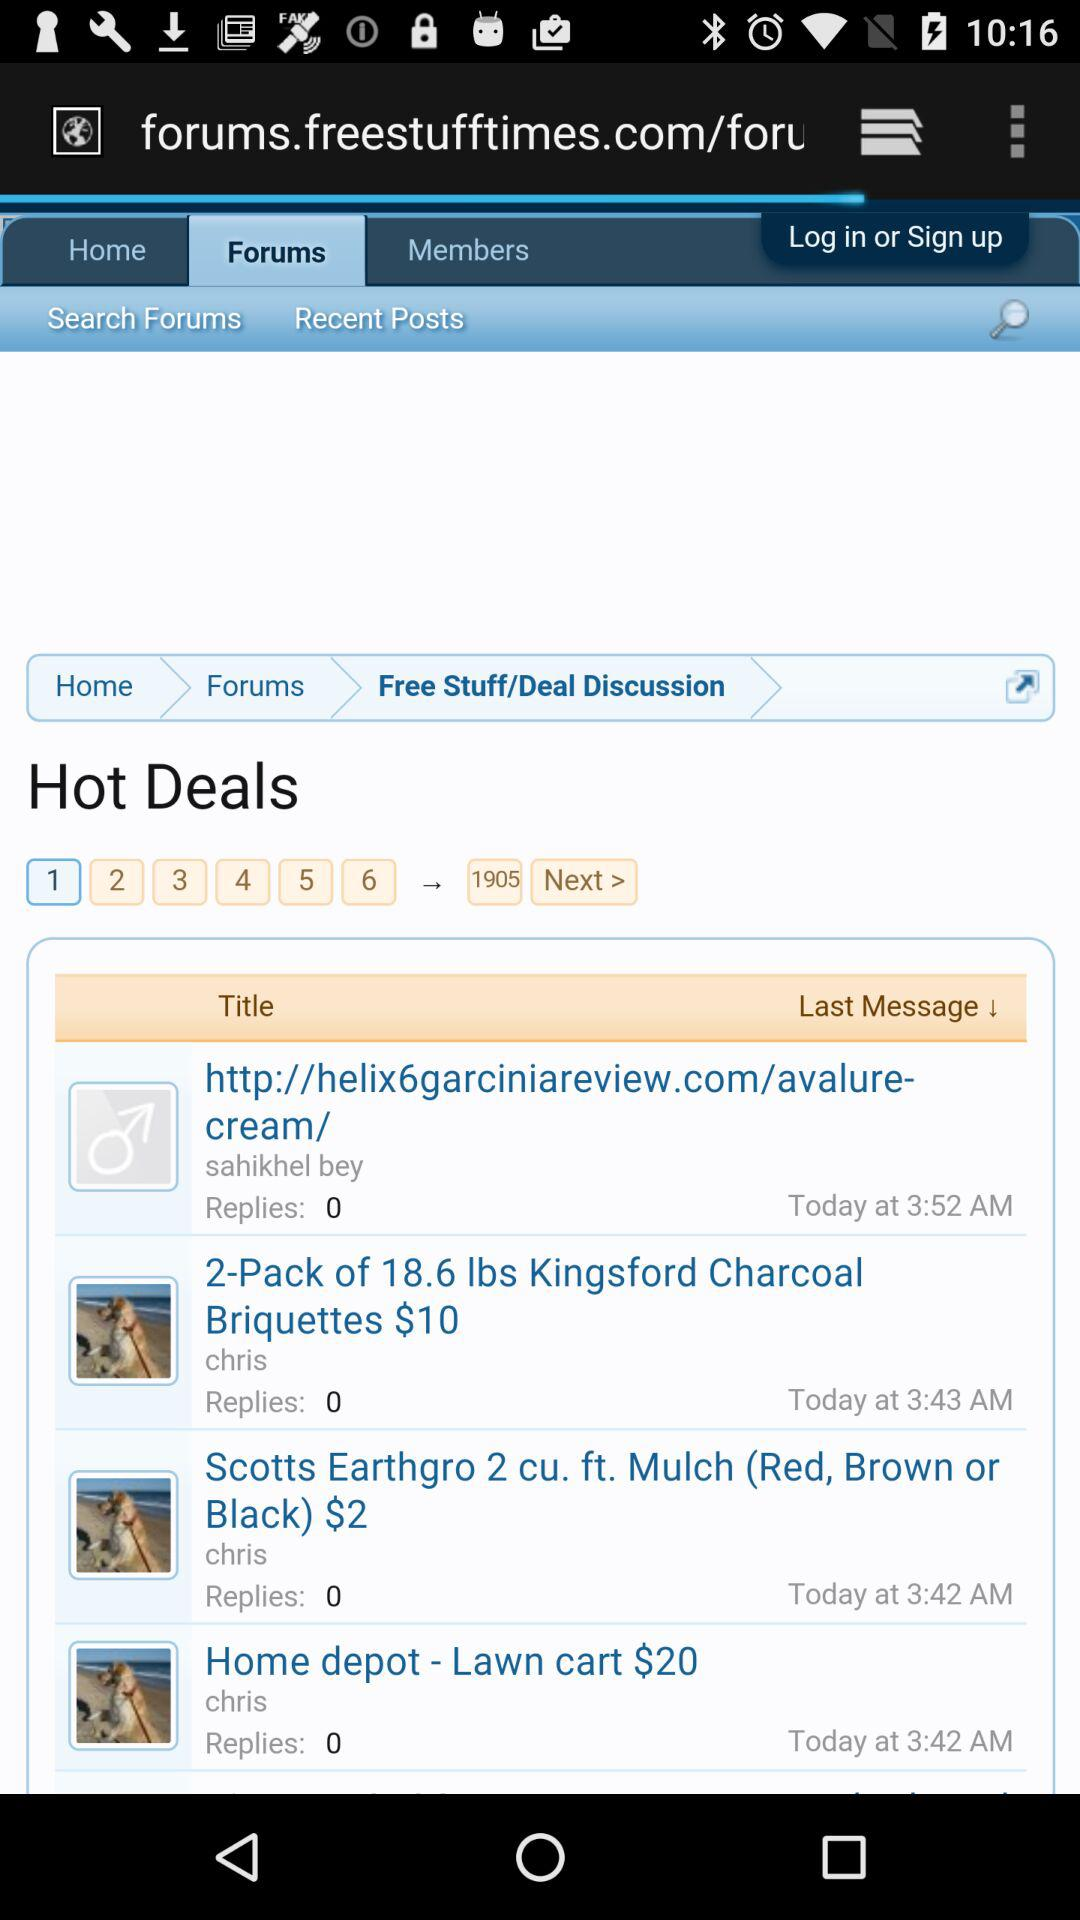What is the time of the last message in "Home depot"? The time is 3:42 a.m. 